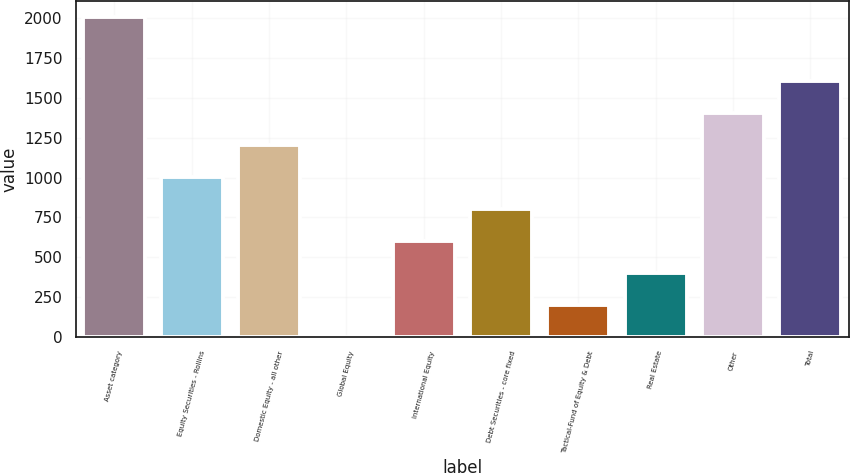Convert chart to OTSL. <chart><loc_0><loc_0><loc_500><loc_500><bar_chart><fcel>Asset category<fcel>Equity Securities - Rollins<fcel>Domestic Equity - all other<fcel>Global Equity<fcel>International Equity<fcel>Debt Securities - core fixed<fcel>Tactical-Fund of Equity & Debt<fcel>Real Estate<fcel>Other<fcel>Total<nl><fcel>2008<fcel>1005.55<fcel>1206.04<fcel>3.1<fcel>604.57<fcel>805.06<fcel>203.59<fcel>404.08<fcel>1406.53<fcel>1607.02<nl></chart> 